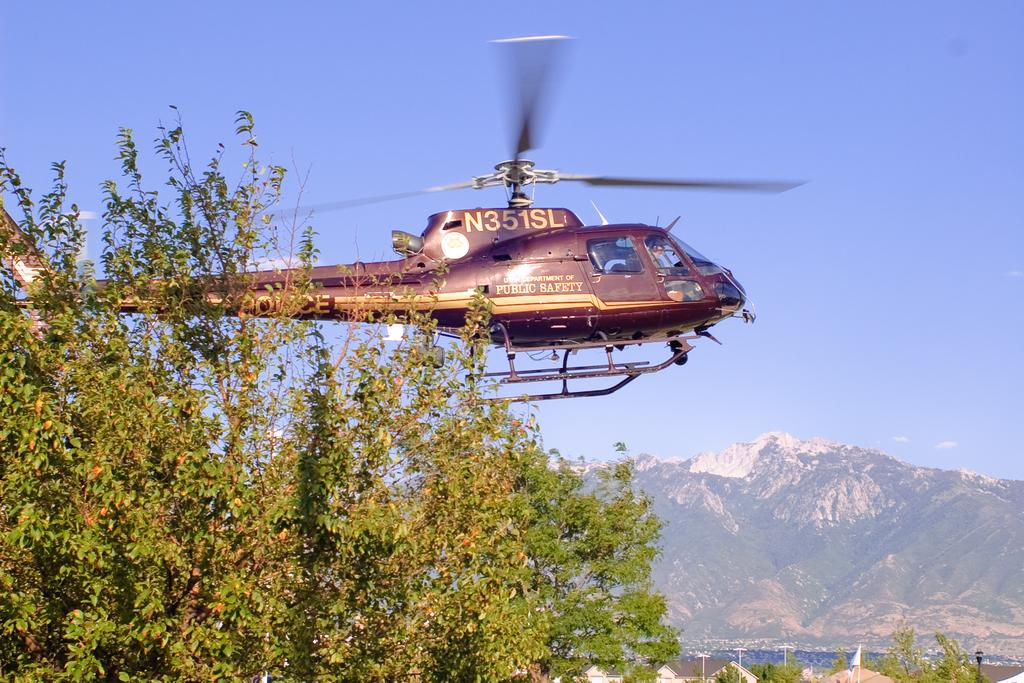<image>
Render a clear and concise summary of the photo. a helicopter with N351SL on it flies above a mountain 